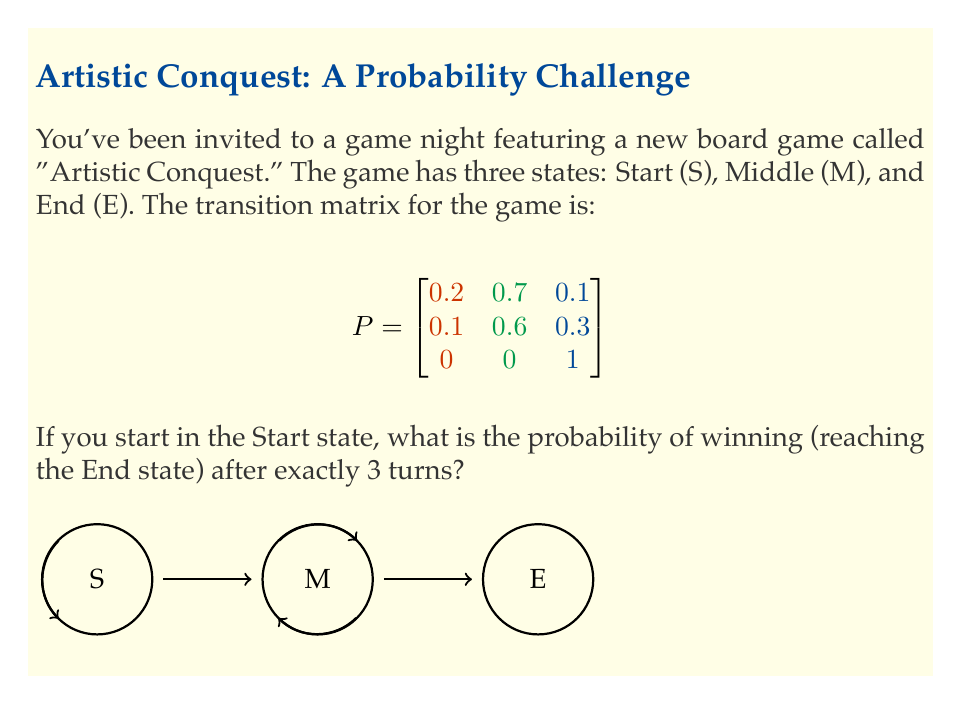Show me your answer to this math problem. Let's approach this step-by-step:

1) The transition matrix $P$ represents the probabilities of moving between states in one turn. We need to calculate the probability of being in state E after exactly 3 turns.

2) To do this, we need to compute $P^3$, which gives us the probabilities of moving between states in exactly 3 turns.

3) We can calculate $P^3$ by multiplying $P$ by itself three times:

   $$P^2 = P \cdot P = \begin{bmatrix}
   0.13 & 0.62 & 0.25 \\
   0.08 & 0.48 & 0.44 \\
   0 & 0 & 1
   \end{bmatrix}$$

   $$P^3 = P^2 \cdot P = \begin{bmatrix}
   0.098 & 0.497 & 0.405 \\
   0.062 & 0.366 & 0.572 \\
   0 & 0 & 1
   \end{bmatrix}$$

4) Since we start in the Start state (S), we're interested in the first row of $P^3$.

5) The probability of being in the End state (E) after exactly 3 turns, starting from the Start state (S), is given by the element in the first row, third column of $P^3$.

6) This probability is 0.405 or 40.5%.
Answer: 0.405 